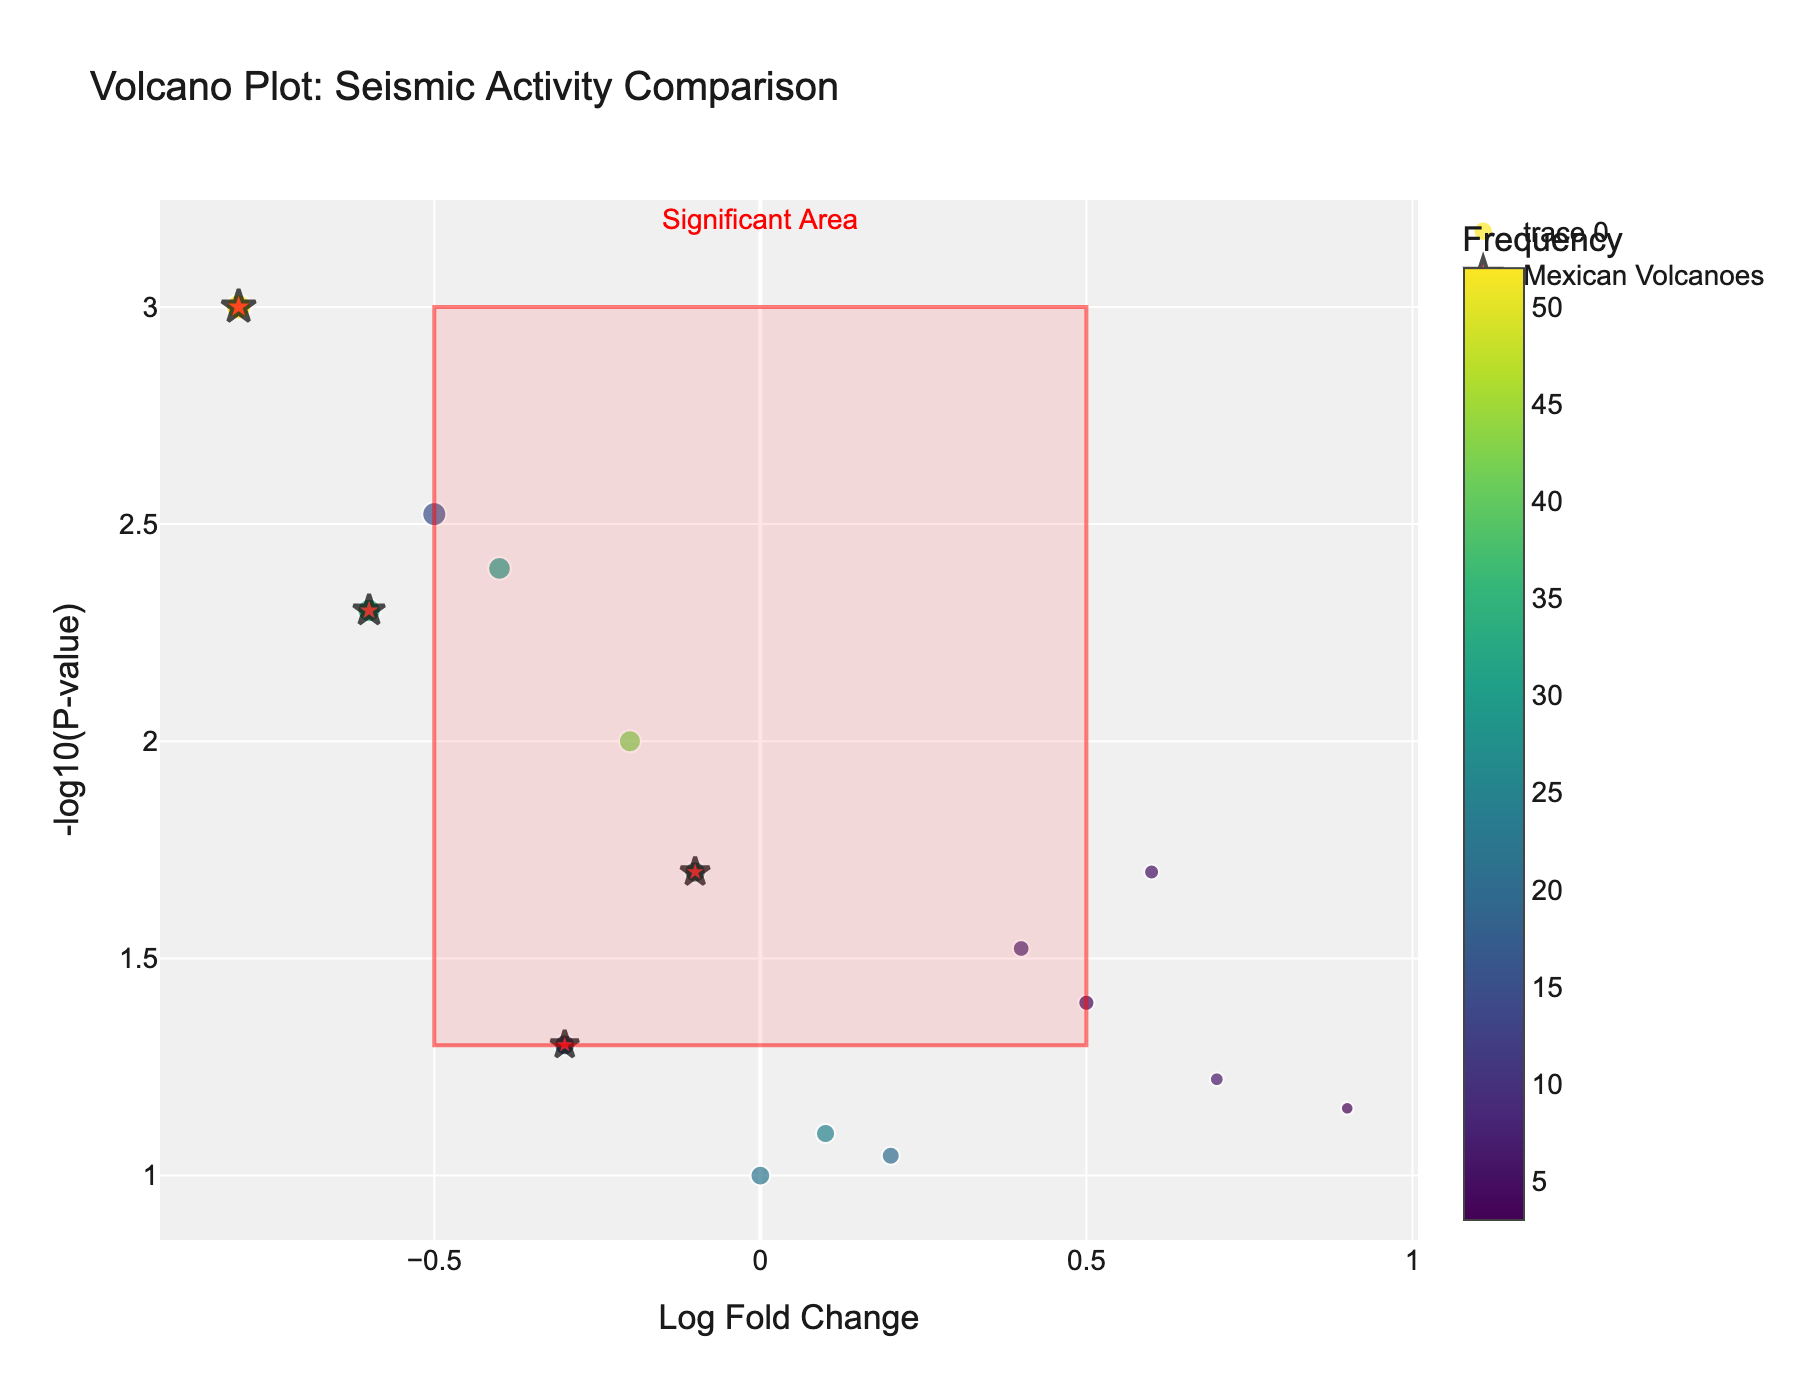How many Mexican volcanoes are highlighted in the plot? In the figure, Mexican volcanoes are highlighted as red stars. By counting these unique symbols, we can identify the number of Mexican volcanoes.
Answer: 4 Which volcano has the highest magnitude? By comparing the sizes of the markers (larger size indicates higher magnitude), we can see that Popocatépetl has the largest marker, indicating the highest magnitude.
Answer: Popocatépetl What is the p-value range for the significant area highlighted in the rectangle? The rectangle section in the plot covers the area from y-values 1.3 to 3. Given the y-axis is -log10(P-value), the corresponding p-value range is from 10^(-3) to 10^(-1.3).
Answer: 0.001 to 0.05 Which non-Mexican volcano has the highest magnitude? Focusing on non-Mexican volcanoes, the largest marker among them belongs to Eyjafjallajökull.
Answer: Eyjafjallajökull What is the frequency range represented by the color scale? The figure includes a color scale bar indicating frequency values. By observing the scale, we infer the range from the lowest to highest frequencies depicted in colors.
Answer: 3 to 52 Which volcanoes fall within the significant area? The significant area is between -0.5 to 0.5 on the x-axis and 1.3 to 3 on the y-axis. Checking the volcanoes within this region on the plot, we find three: Iztaccíhuatl, Colima, and Mount Etna.
Answer: Iztaccíhuatl, Colima, Mount Etna Which Mexican volcano has the lowest magnitude? Among the highlighted markers (stars) for Mexican volcanoes, the smallest marker size corresponds to Iztaccíhuatl.
Answer: Iztaccíhuatl Which volcano has the highest fold change? Fold change is represented on the x-axis. The volcano with the highest positive x-value is Mount Kilimanjaro.
Answer: Mount Kilimanjaro What is the relation between LogFC and P-value for Mount Fuji? By locating the point for Mount Fuji on the plot and checking its coordinates, we see it has a positive LogFC value and a relatively low p-value (indicating statistical significance).
Answer: Positive LogFC, low P-value How does the frequency of Popocatépetl compare to Mount Vesuvius? By observing the marker colors (which indicate frequency), Popocatépetl has a darker color (higher frequency) compared to Mount Vesuvius.
Answer: Popocatépetl has a higher frequency 